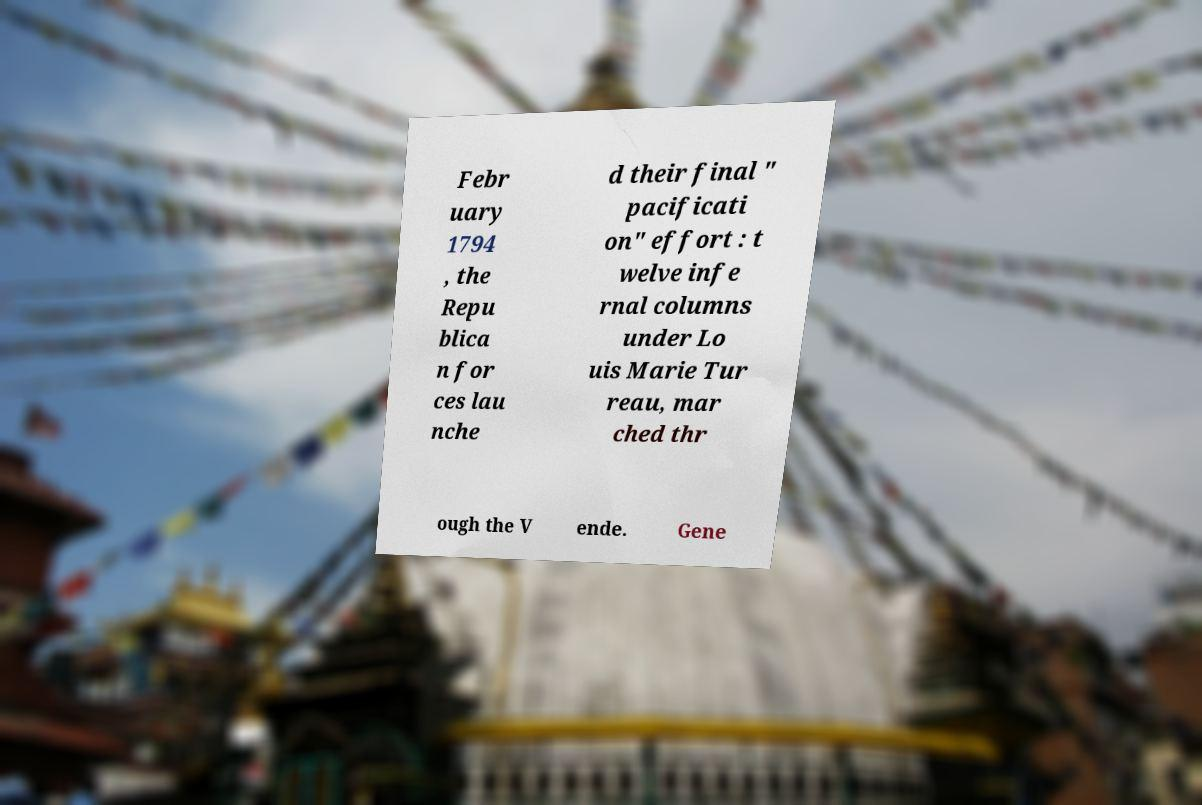Could you extract and type out the text from this image? Febr uary 1794 , the Repu blica n for ces lau nche d their final " pacificati on" effort : t welve infe rnal columns under Lo uis Marie Tur reau, mar ched thr ough the V ende. Gene 